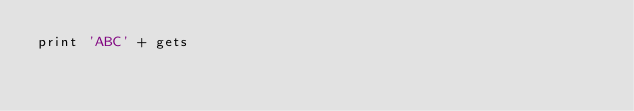<code> <loc_0><loc_0><loc_500><loc_500><_Ruby_>print 'ABC' + gets</code> 